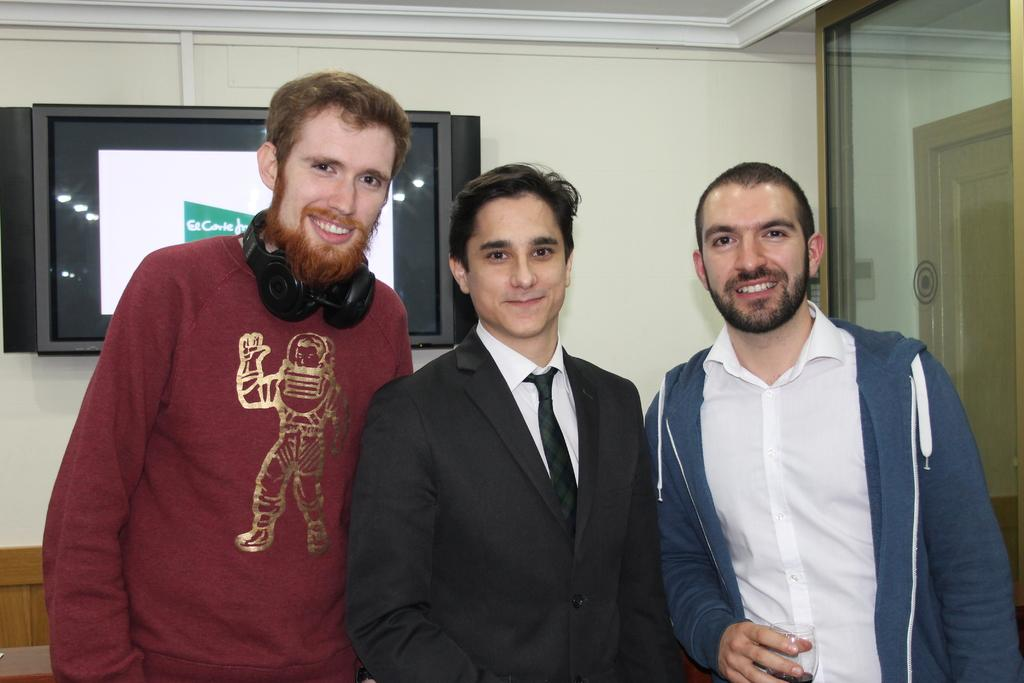How many people are present in the image? There are three people in the image. What is the facial expression of the people in the image? The people are smiling. What can be seen in the background of the image? There is a wall, a screen, and a mirror in the background of the image. What is the opinion of the cushion in the image? There is no cushion present in the image, so it is not possible to determine its opinion. 